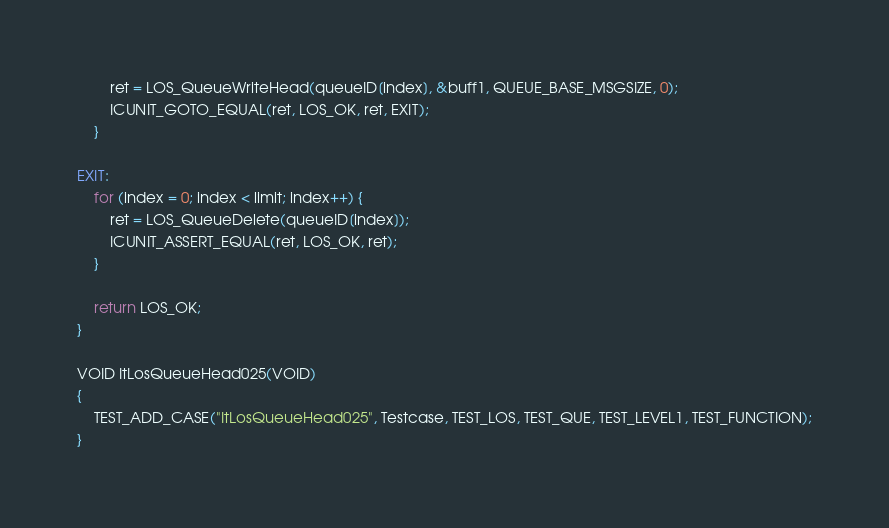Convert code to text. <code><loc_0><loc_0><loc_500><loc_500><_C_>        ret = LOS_QueueWriteHead(queueID[index], &buff1, QUEUE_BASE_MSGSIZE, 0);
        ICUNIT_GOTO_EQUAL(ret, LOS_OK, ret, EXIT);
    }

EXIT:
    for (index = 0; index < limit; index++) {
        ret = LOS_QueueDelete(queueID[index]);
        ICUNIT_ASSERT_EQUAL(ret, LOS_OK, ret);
    }

    return LOS_OK;
}

VOID ItLosQueueHead025(VOID)
{
    TEST_ADD_CASE("ItLosQueueHead025", Testcase, TEST_LOS, TEST_QUE, TEST_LEVEL1, TEST_FUNCTION);
}

</code> 